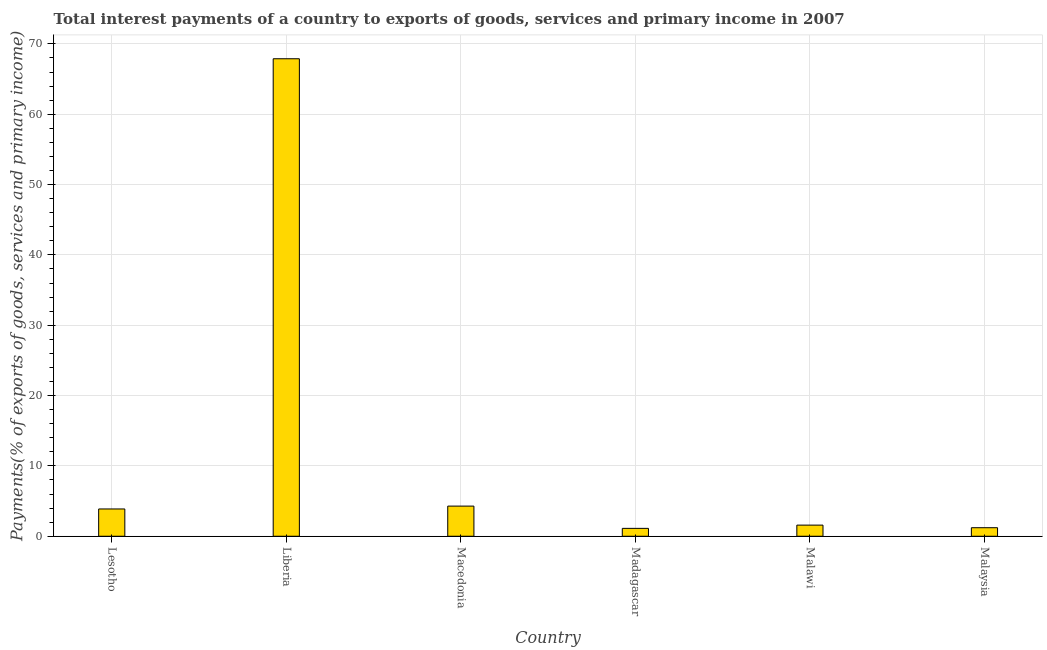Does the graph contain grids?
Give a very brief answer. Yes. What is the title of the graph?
Offer a very short reply. Total interest payments of a country to exports of goods, services and primary income in 2007. What is the label or title of the Y-axis?
Offer a very short reply. Payments(% of exports of goods, services and primary income). What is the total interest payments on external debt in Malaysia?
Keep it short and to the point. 1.21. Across all countries, what is the maximum total interest payments on external debt?
Provide a succinct answer. 67.89. Across all countries, what is the minimum total interest payments on external debt?
Your response must be concise. 1.12. In which country was the total interest payments on external debt maximum?
Make the answer very short. Liberia. In which country was the total interest payments on external debt minimum?
Make the answer very short. Madagascar. What is the sum of the total interest payments on external debt?
Keep it short and to the point. 79.97. What is the difference between the total interest payments on external debt in Liberia and Malaysia?
Your answer should be compact. 66.67. What is the average total interest payments on external debt per country?
Provide a short and direct response. 13.33. What is the median total interest payments on external debt?
Ensure brevity in your answer.  2.73. In how many countries, is the total interest payments on external debt greater than 10 %?
Give a very brief answer. 1. What is the ratio of the total interest payments on external debt in Lesotho to that in Liberia?
Give a very brief answer. 0.06. What is the difference between the highest and the second highest total interest payments on external debt?
Ensure brevity in your answer.  63.6. What is the difference between the highest and the lowest total interest payments on external debt?
Give a very brief answer. 66.77. In how many countries, is the total interest payments on external debt greater than the average total interest payments on external debt taken over all countries?
Provide a short and direct response. 1. How many countries are there in the graph?
Make the answer very short. 6. What is the Payments(% of exports of goods, services and primary income) in Lesotho?
Offer a terse response. 3.88. What is the Payments(% of exports of goods, services and primary income) in Liberia?
Keep it short and to the point. 67.89. What is the Payments(% of exports of goods, services and primary income) of Macedonia?
Your response must be concise. 4.29. What is the Payments(% of exports of goods, services and primary income) in Madagascar?
Your response must be concise. 1.12. What is the Payments(% of exports of goods, services and primary income) of Malawi?
Make the answer very short. 1.58. What is the Payments(% of exports of goods, services and primary income) of Malaysia?
Provide a short and direct response. 1.21. What is the difference between the Payments(% of exports of goods, services and primary income) in Lesotho and Liberia?
Your answer should be compact. -64.01. What is the difference between the Payments(% of exports of goods, services and primary income) in Lesotho and Macedonia?
Provide a succinct answer. -0.41. What is the difference between the Payments(% of exports of goods, services and primary income) in Lesotho and Madagascar?
Offer a very short reply. 2.76. What is the difference between the Payments(% of exports of goods, services and primary income) in Lesotho and Malawi?
Your response must be concise. 2.3. What is the difference between the Payments(% of exports of goods, services and primary income) in Lesotho and Malaysia?
Your answer should be compact. 2.66. What is the difference between the Payments(% of exports of goods, services and primary income) in Liberia and Macedonia?
Offer a very short reply. 63.6. What is the difference between the Payments(% of exports of goods, services and primary income) in Liberia and Madagascar?
Offer a terse response. 66.77. What is the difference between the Payments(% of exports of goods, services and primary income) in Liberia and Malawi?
Your answer should be very brief. 66.3. What is the difference between the Payments(% of exports of goods, services and primary income) in Liberia and Malaysia?
Ensure brevity in your answer.  66.67. What is the difference between the Payments(% of exports of goods, services and primary income) in Macedonia and Madagascar?
Your response must be concise. 3.17. What is the difference between the Payments(% of exports of goods, services and primary income) in Macedonia and Malawi?
Make the answer very short. 2.7. What is the difference between the Payments(% of exports of goods, services and primary income) in Macedonia and Malaysia?
Make the answer very short. 3.07. What is the difference between the Payments(% of exports of goods, services and primary income) in Madagascar and Malawi?
Keep it short and to the point. -0.46. What is the difference between the Payments(% of exports of goods, services and primary income) in Madagascar and Malaysia?
Provide a succinct answer. -0.09. What is the difference between the Payments(% of exports of goods, services and primary income) in Malawi and Malaysia?
Make the answer very short. 0.37. What is the ratio of the Payments(% of exports of goods, services and primary income) in Lesotho to that in Liberia?
Your response must be concise. 0.06. What is the ratio of the Payments(% of exports of goods, services and primary income) in Lesotho to that in Macedonia?
Your response must be concise. 0.91. What is the ratio of the Payments(% of exports of goods, services and primary income) in Lesotho to that in Madagascar?
Your response must be concise. 3.46. What is the ratio of the Payments(% of exports of goods, services and primary income) in Lesotho to that in Malawi?
Make the answer very short. 2.45. What is the ratio of the Payments(% of exports of goods, services and primary income) in Lesotho to that in Malaysia?
Keep it short and to the point. 3.19. What is the ratio of the Payments(% of exports of goods, services and primary income) in Liberia to that in Macedonia?
Offer a terse response. 15.84. What is the ratio of the Payments(% of exports of goods, services and primary income) in Liberia to that in Madagascar?
Ensure brevity in your answer.  60.58. What is the ratio of the Payments(% of exports of goods, services and primary income) in Liberia to that in Malawi?
Offer a terse response. 42.89. What is the ratio of the Payments(% of exports of goods, services and primary income) in Liberia to that in Malaysia?
Offer a very short reply. 55.89. What is the ratio of the Payments(% of exports of goods, services and primary income) in Macedonia to that in Madagascar?
Your response must be concise. 3.83. What is the ratio of the Payments(% of exports of goods, services and primary income) in Macedonia to that in Malawi?
Your response must be concise. 2.71. What is the ratio of the Payments(% of exports of goods, services and primary income) in Macedonia to that in Malaysia?
Make the answer very short. 3.53. What is the ratio of the Payments(% of exports of goods, services and primary income) in Madagascar to that in Malawi?
Keep it short and to the point. 0.71. What is the ratio of the Payments(% of exports of goods, services and primary income) in Madagascar to that in Malaysia?
Make the answer very short. 0.92. What is the ratio of the Payments(% of exports of goods, services and primary income) in Malawi to that in Malaysia?
Make the answer very short. 1.3. 